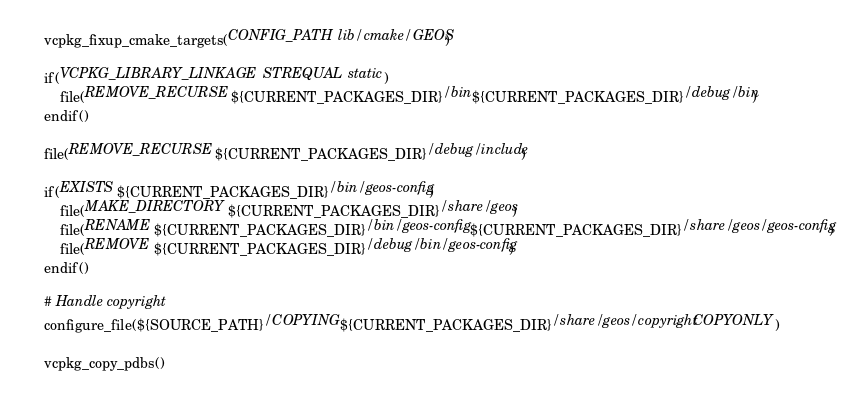<code> <loc_0><loc_0><loc_500><loc_500><_CMake_>vcpkg_fixup_cmake_targets(CONFIG_PATH lib/cmake/GEOS)

if(VCPKG_LIBRARY_LINKAGE STREQUAL static)
    file(REMOVE_RECURSE ${CURRENT_PACKAGES_DIR}/bin ${CURRENT_PACKAGES_DIR}/debug/bin)
endif()

file(REMOVE_RECURSE ${CURRENT_PACKAGES_DIR}/debug/include)

if(EXISTS ${CURRENT_PACKAGES_DIR}/bin/geos-config)
    file(MAKE_DIRECTORY ${CURRENT_PACKAGES_DIR}/share/geos)
    file(RENAME ${CURRENT_PACKAGES_DIR}/bin/geos-config ${CURRENT_PACKAGES_DIR}/share/geos/geos-config)
    file(REMOVE ${CURRENT_PACKAGES_DIR}/debug/bin/geos-config)
endif()

# Handle copyright
configure_file(${SOURCE_PATH}/COPYING ${CURRENT_PACKAGES_DIR}/share/geos/copyright COPYONLY)

vcpkg_copy_pdbs()
</code> 